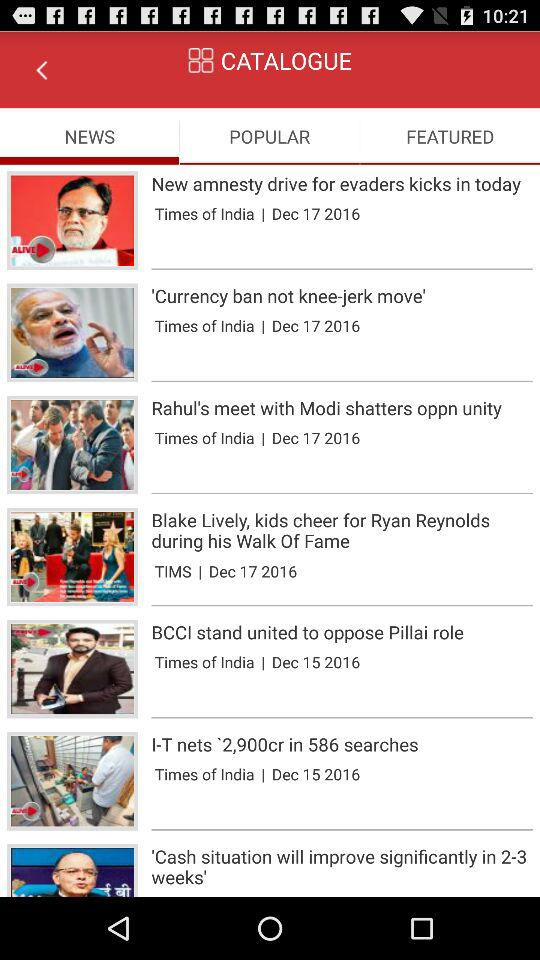Which tab am I on? You are on the "NEWS" tab. 